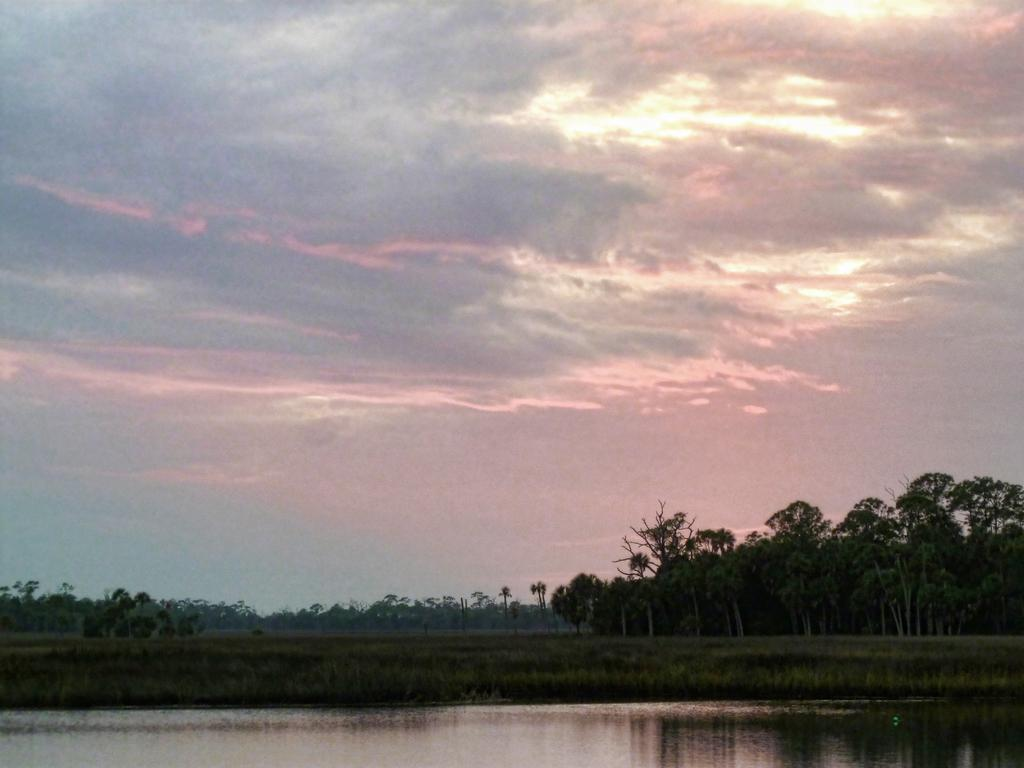What is the primary element visible in the image? There is water in the image. What type of vegetation can be seen in the image? There is grass and trees in the image. What is visible in the background of the image? The sky is visible in the background of the image. What can be observed in the sky? Clouds are present in the sky. How many snails are crawling on the plot in the image? There are no snails or plots present in the image. What type of activity can be observed as people join the gathering in the image? There is no gathering or joining activity present in the image. 